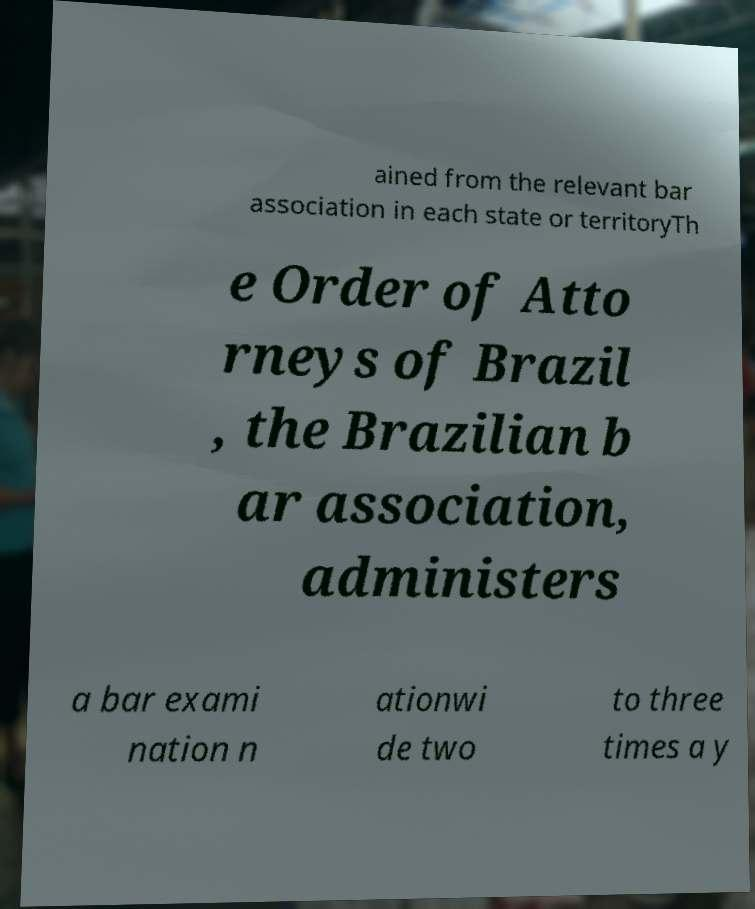Can you accurately transcribe the text from the provided image for me? ained from the relevant bar association in each state or territoryTh e Order of Atto rneys of Brazil , the Brazilian b ar association, administers a bar exami nation n ationwi de two to three times a y 